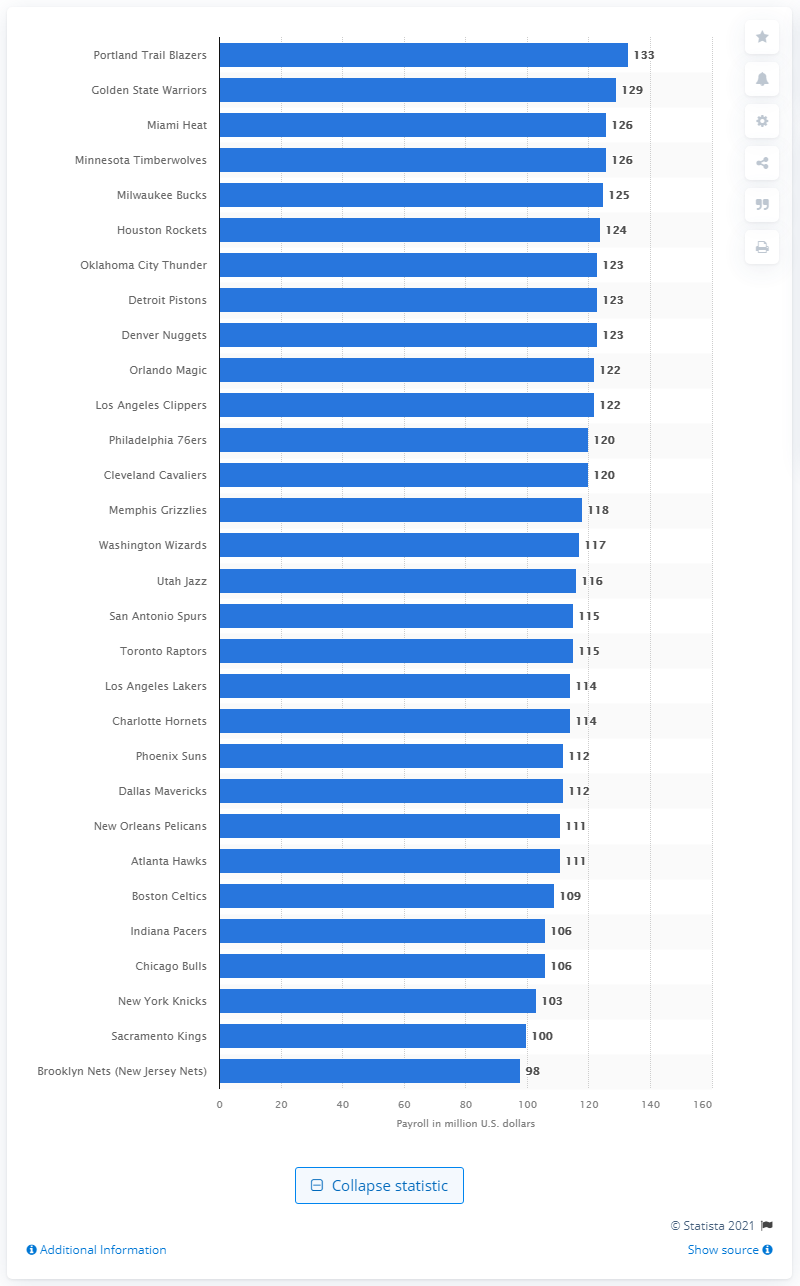Highlight a few significant elements in this photo. The Los Angeles Lakers spent 115 million dollars on player salaries in the 2019/20 season. 